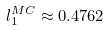<formula> <loc_0><loc_0><loc_500><loc_500>l _ { 1 } ^ { M C } \approx 0 . 4 7 6 2</formula> 